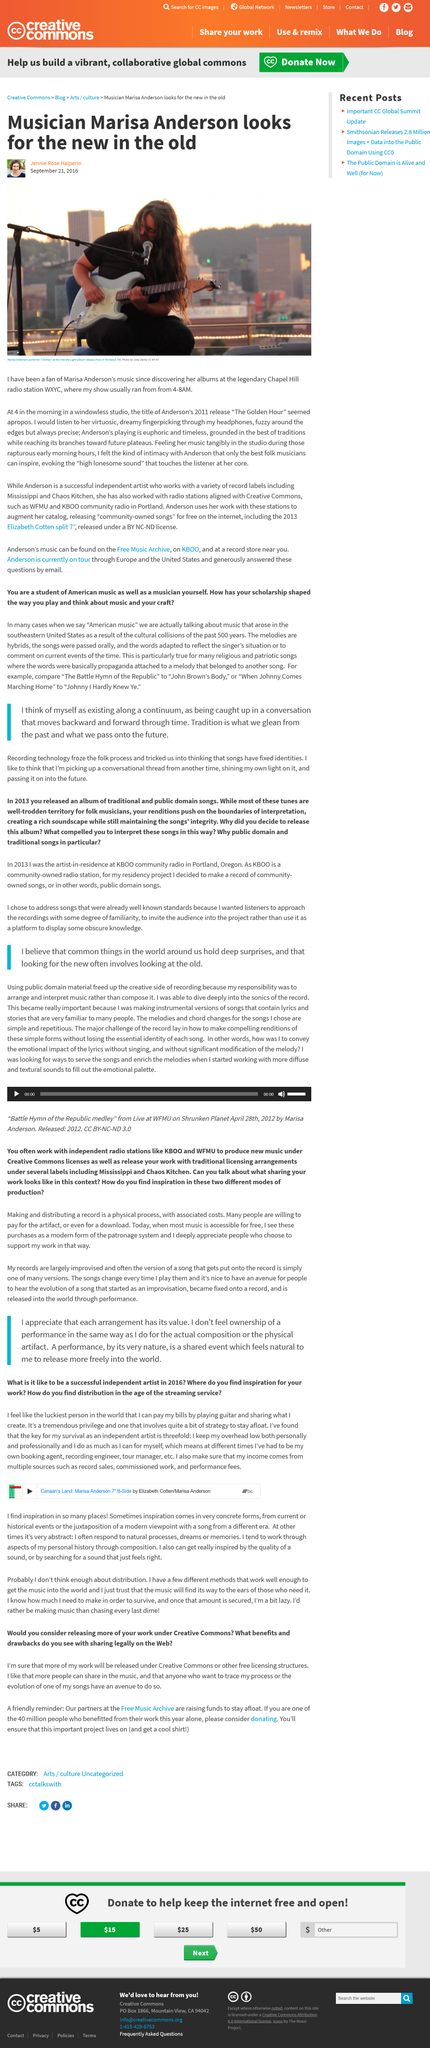Outline some significant characteristics in this image. Marisa Anderson plays the guitar. Jennie Rose Halperin discovered Marisa Anderson's music on Chapel Hill radio station WXYC. The Free Music Archives is in need of financial support to continue its operation. One way to aid in this effort is to donate to the organization, as those who have benefited from the site are encouraged to give back. I choose to release my work under a Creative Common licensing structure because it allows for increased sharing and tracing of my music, as well as the evolution of my songs over time. Donating to the Free Music Archive ensures the continued existence of the site and provides the opportunity to receive a cool t-shirt as a reward. 